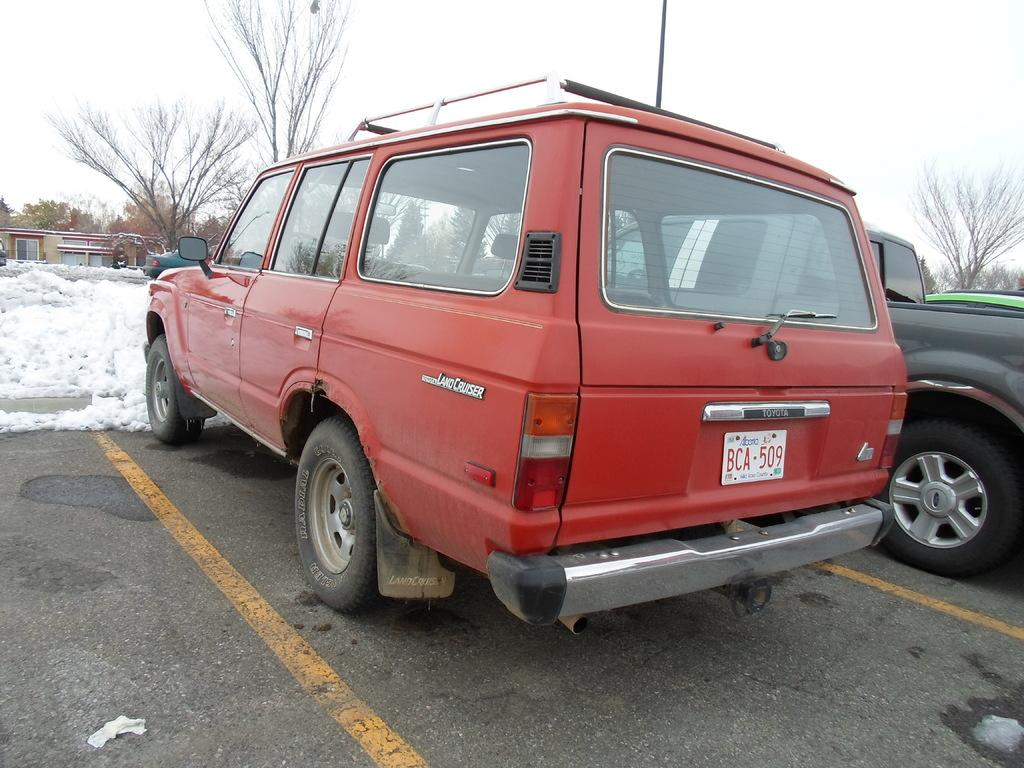What is happening on the road in the image? There are vehicles on the road in the image. What type of weather is depicted in the image? There is snow visible in the image. What can be seen in the background of the image? There are trees in the image. What object is present in the image that is not a vehicle or tree? There is a pole in the image. What is visible at the top of the image? The sky is visible at the top of the image. What type of sock is hanging on the pole in the image? There is no sock present in the image; only vehicles, snow, trees, a pole, and the sky are visible. What items are on the list that is visible in the image? There is no list present in the image. 